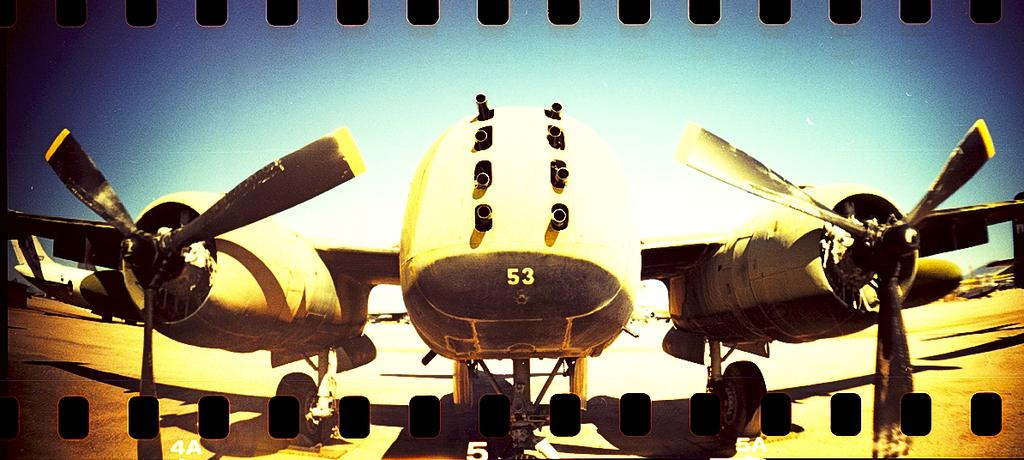What is the main subject of the image? The main subject of the image is an aircraft. Are there any words or letters on the aircraft? Yes, there is text on the aircraft. What is visible in the background of the image? The sky is visible at the top of the image. Is there any text outside of the aircraft in the image? Yes, there is text at the bottom of the image. How many potatoes are visible in the image? There are no potatoes present in the image. Are there any trees in the image? The provided facts do not mention trees, and there is no indication of trees in the image. 